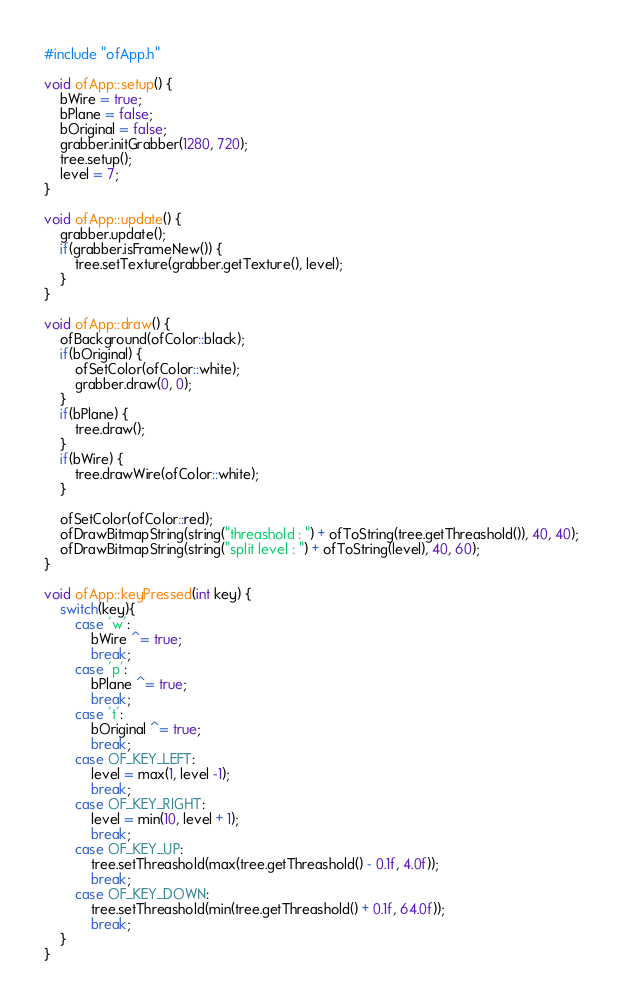<code> <loc_0><loc_0><loc_500><loc_500><_C++_>#include "ofApp.h"

void ofApp::setup() {
    bWire = true;
    bPlane = false;
    bOriginal = false;
    grabber.initGrabber(1280, 720);
    tree.setup();
    level = 7;
}

void ofApp::update() {
    grabber.update();
    if(grabber.isFrameNew()) {
        tree.setTexture(grabber.getTexture(), level);
    }
}

void ofApp::draw() {
    ofBackground(ofColor::black);
    if(bOriginal) {
        ofSetColor(ofColor::white);
        grabber.draw(0, 0);
    }
    if(bPlane) {
        tree.draw();
    }
    if(bWire) {
        tree.drawWire(ofColor::white);
    }
    
    ofSetColor(ofColor::red);
    ofDrawBitmapString(string("threashold : ") + ofToString(tree.getThreashold()), 40, 40);
    ofDrawBitmapString(string("split level : ") + ofToString(level), 40, 60);
}

void ofApp::keyPressed(int key) {
    switch(key){
        case 'w':
            bWire ^= true;
            break;
        case 'p':
            bPlane ^= true;
            break;
        case 't':
            bOriginal ^= true;
            break;
        case OF_KEY_LEFT:
            level = max(1, level -1);
            break;
        case OF_KEY_RIGHT:
            level = min(10, level + 1);
            break;
        case OF_KEY_UP:
            tree.setThreashold(max(tree.getThreashold() - 0.1f, 4.0f));
            break;
        case OF_KEY_DOWN:
            tree.setThreashold(min(tree.getThreashold() + 0.1f, 64.0f));
            break;
    }
}
</code> 